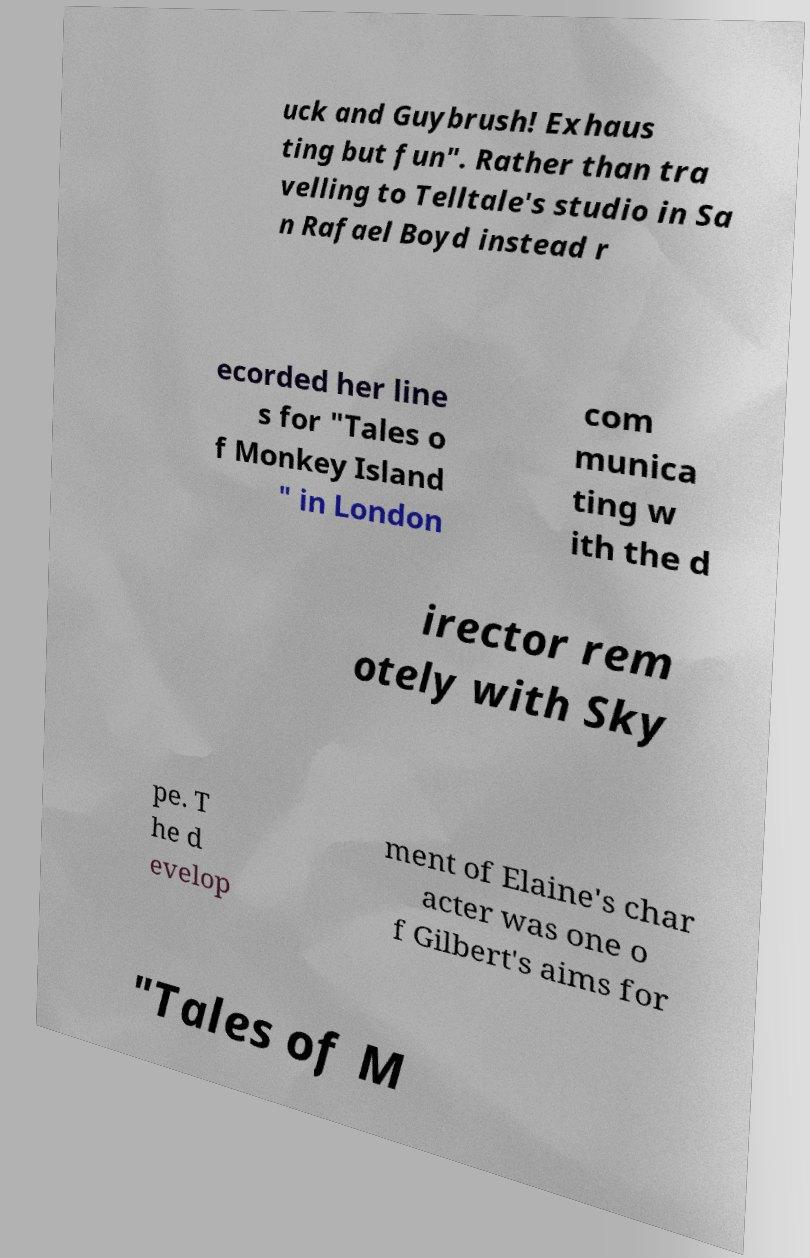For documentation purposes, I need the text within this image transcribed. Could you provide that? uck and Guybrush! Exhaus ting but fun". Rather than tra velling to Telltale's studio in Sa n Rafael Boyd instead r ecorded her line s for "Tales o f Monkey Island " in London com munica ting w ith the d irector rem otely with Sky pe. T he d evelop ment of Elaine's char acter was one o f Gilbert's aims for "Tales of M 